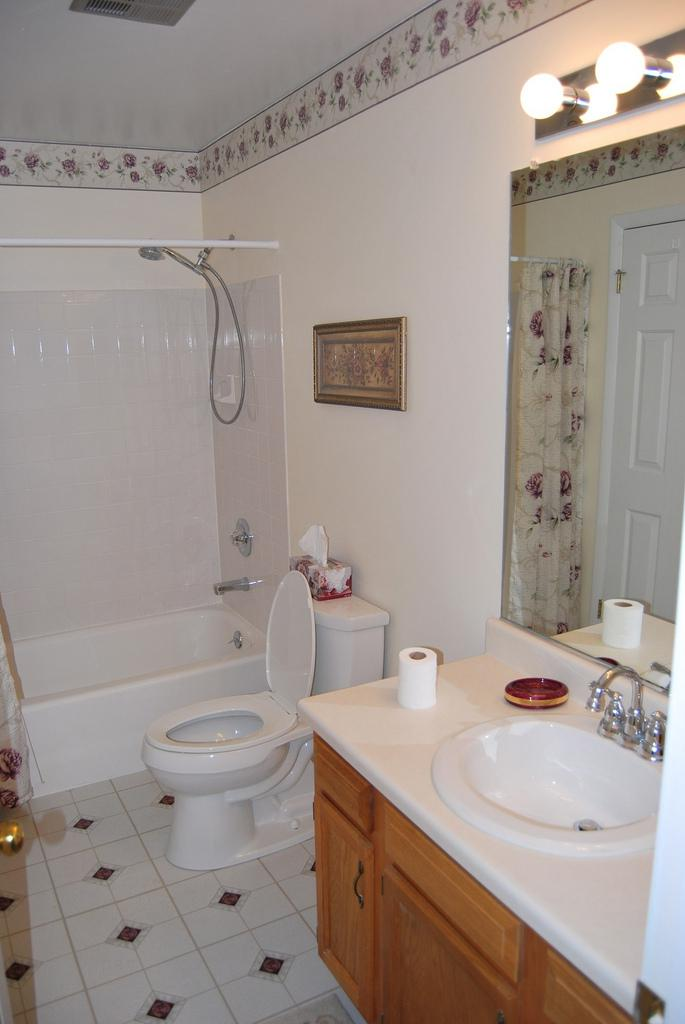Question: what is reflected in the mirror?
Choices:
A. The tub.
B. The tiles on the wall.
C. The shower curtain.
D. The sink.
Answer with the letter. Answer: C Question: what pattern is on the tile?
Choices:
A. A triangle pattern.
B. A star pattern.
C. A flag pattern.
D. A diamond pattern.
Answer with the letter. Answer: D Question: what are the cabinets made out of?
Choices:
A. Plastic.
B. Glass.
C. Marble.
D. Wood.
Answer with the letter. Answer: D Question: what color is the doorknob?
Choices:
A. Silver.
B. Black.
C. Purple.
D. Gold.
Answer with the letter. Answer: D Question: what is on the back of the toilet?
Choices:
A. Magazines.
B. Hand Towel.
C. Tissues.
D. Candles.
Answer with the letter. Answer: C Question: what is the floor made out of?
Choices:
A. Hardwood.
B. Carpet.
C. Linoleum.
D. Tile.
Answer with the letter. Answer: D Question: what is the position of the toilet seat?
Choices:
A. The seat is down.
B. The seat is to the left of the sink.
C. The seat is up.
D. The seat is in a 45 degree angle.
Answer with the letter. Answer: C Question: what does the bathroom tile look like?
Choices:
A. The tile has squares and red diamonds.
B. The tiles are rectangle.
C. The tiles are triangle in shape.
D. The tiles are circular.
Answer with the letter. Answer: A Question: what does the bathroom look like?
Choices:
A. The bathroom has a ceramic toilet, and a large shower area.
B. The bathroom is decorated with pink carpets.
C. The cabinets are light wood, while the counter and sink are white, and a mirror is available.
D. The bathroom has a dryer and dispensable paper towels.
Answer with the letter. Answer: C Question: what metal are the sink fixtures made of?
Choices:
A. Iron.
B. Brushed Nickel.
C. Stainless Steel.
D. Chrome.
Answer with the letter. Answer: D Question: what pattern is on the shower curtain?
Choices:
A. Daisies.
B. Roses.
C. Tulips.
D. Carnations.
Answer with the letter. Answer: B Question: what is the cabinet made of?
Choices:
A. Particle board.
B. Plastic.
C. Wood.
D. Metal.
Answer with the letter. Answer: C Question: what does the tub look like?
Choices:
A. The tub is large.
B. The tub has a lot of room.
C. It is shallow and white with a moveable showerhead.
D. The tub has a ceramic finish.
Answer with the letter. Answer: C Question: what is not running?
Choices:
A. The taps.
B. The refrigerator.
C. The dog.
D. The clock.
Answer with the letter. Answer: A Question: what material are the drawers made of?
Choices:
A. Plastic.
B. Cardboard.
C. Metal.
D. Wood.
Answer with the letter. Answer: D 